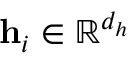<formula> <loc_0><loc_0><loc_500><loc_500>h _ { i } \in \mathbb { R } ^ { d _ { h } }</formula> 